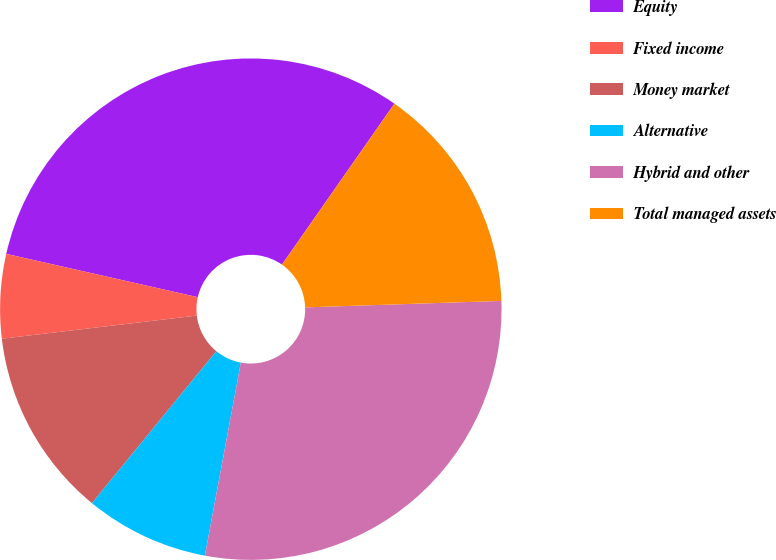Convert chart to OTSL. <chart><loc_0><loc_0><loc_500><loc_500><pie_chart><fcel>Equity<fcel>Fixed income<fcel>Money market<fcel>Alternative<fcel>Hybrid and other<fcel>Total managed assets<nl><fcel>31.17%<fcel>5.42%<fcel>12.2%<fcel>7.99%<fcel>28.46%<fcel>14.77%<nl></chart> 